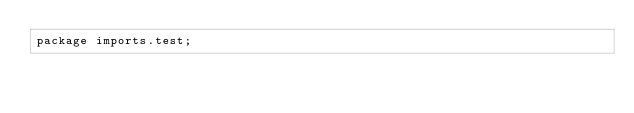<code> <loc_0><loc_0><loc_500><loc_500><_Ceylon_>package imports.test;</code> 